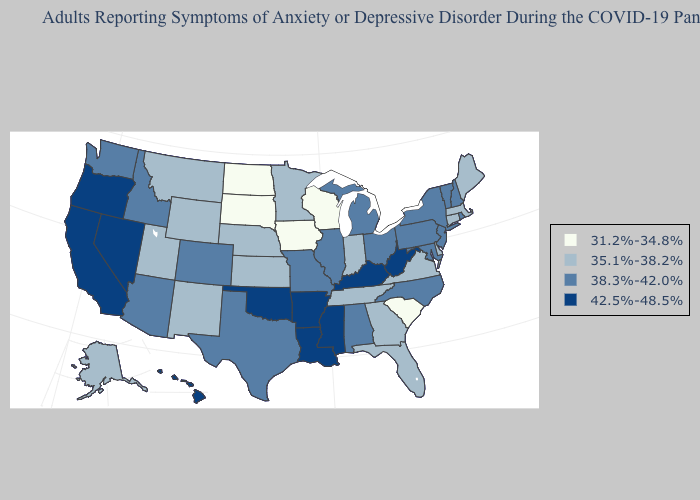Does South Carolina have the lowest value in the South?
Keep it brief. Yes. What is the value of Georgia?
Keep it brief. 35.1%-38.2%. Name the states that have a value in the range 42.5%-48.5%?
Answer briefly. Arkansas, California, Hawaii, Kentucky, Louisiana, Mississippi, Nevada, Oklahoma, Oregon, West Virginia. Name the states that have a value in the range 42.5%-48.5%?
Quick response, please. Arkansas, California, Hawaii, Kentucky, Louisiana, Mississippi, Nevada, Oklahoma, Oregon, West Virginia. Name the states that have a value in the range 35.1%-38.2%?
Answer briefly. Alaska, Connecticut, Delaware, Florida, Georgia, Indiana, Kansas, Maine, Massachusetts, Minnesota, Montana, Nebraska, New Mexico, Tennessee, Utah, Virginia, Wyoming. Does Massachusetts have the highest value in the Northeast?
Give a very brief answer. No. What is the value of Wyoming?
Be succinct. 35.1%-38.2%. How many symbols are there in the legend?
Answer briefly. 4. Name the states that have a value in the range 31.2%-34.8%?
Keep it brief. Iowa, North Dakota, South Carolina, South Dakota, Wisconsin. Name the states that have a value in the range 38.3%-42.0%?
Quick response, please. Alabama, Arizona, Colorado, Idaho, Illinois, Maryland, Michigan, Missouri, New Hampshire, New Jersey, New York, North Carolina, Ohio, Pennsylvania, Rhode Island, Texas, Vermont, Washington. Name the states that have a value in the range 42.5%-48.5%?
Write a very short answer. Arkansas, California, Hawaii, Kentucky, Louisiana, Mississippi, Nevada, Oklahoma, Oregon, West Virginia. Is the legend a continuous bar?
Answer briefly. No. Name the states that have a value in the range 31.2%-34.8%?
Concise answer only. Iowa, North Dakota, South Carolina, South Dakota, Wisconsin. What is the lowest value in the USA?
Answer briefly. 31.2%-34.8%. 